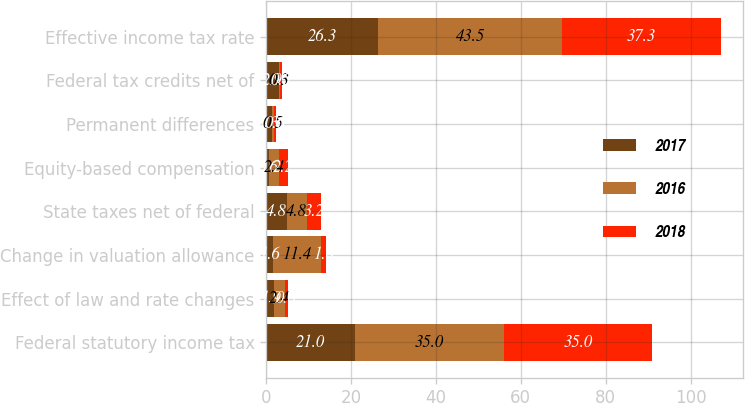Convert chart. <chart><loc_0><loc_0><loc_500><loc_500><stacked_bar_chart><ecel><fcel>Federal statutory income tax<fcel>Effect of law and rate changes<fcel>Change in valuation allowance<fcel>State taxes net of federal<fcel>Equity-based compensation<fcel>Permanent differences<fcel>Federal tax credits net of<fcel>Effective income tax rate<nl><fcel>2017<fcel>21<fcel>1.9<fcel>1.6<fcel>4.8<fcel>0.6<fcel>1.3<fcel>2.9<fcel>26.3<nl><fcel>2016<fcel>35<fcel>2.4<fcel>11.4<fcel>4.8<fcel>2.4<fcel>0.5<fcel>0.3<fcel>43.5<nl><fcel>2018<fcel>35<fcel>0.8<fcel>1<fcel>3.2<fcel>2.2<fcel>0.6<fcel>0.5<fcel>37.3<nl></chart> 